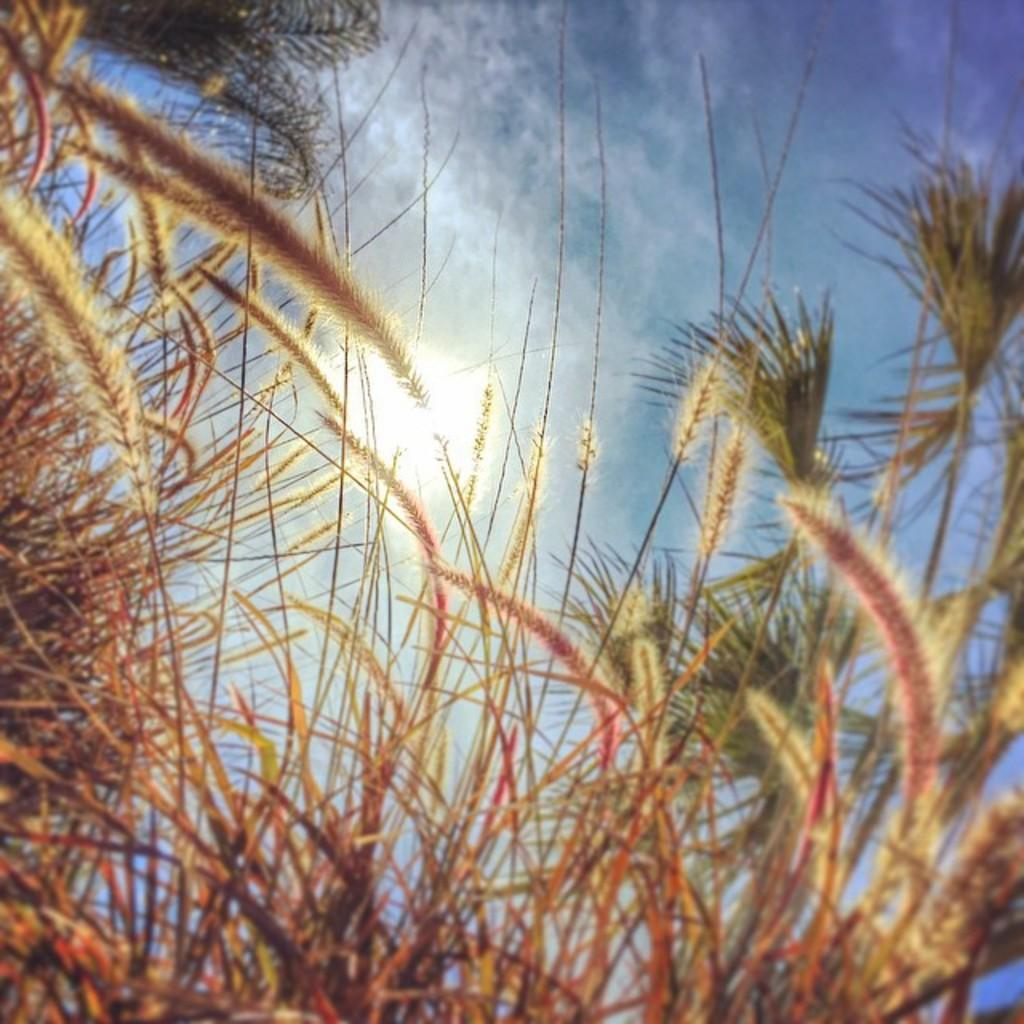What type of vegetation is present at the bottom of the image? There are plants at the bottom of the image. What part of the natural environment is visible at the top of the image? The sky is visible at the top of the image. What type of tail can be seen on the plants in the image? There are no tails present on the plants in the image. What learning materials can be seen in the image? There is no indication of learning materials in the image. Is there any fire visible in the image? There is no fire present in the image. 